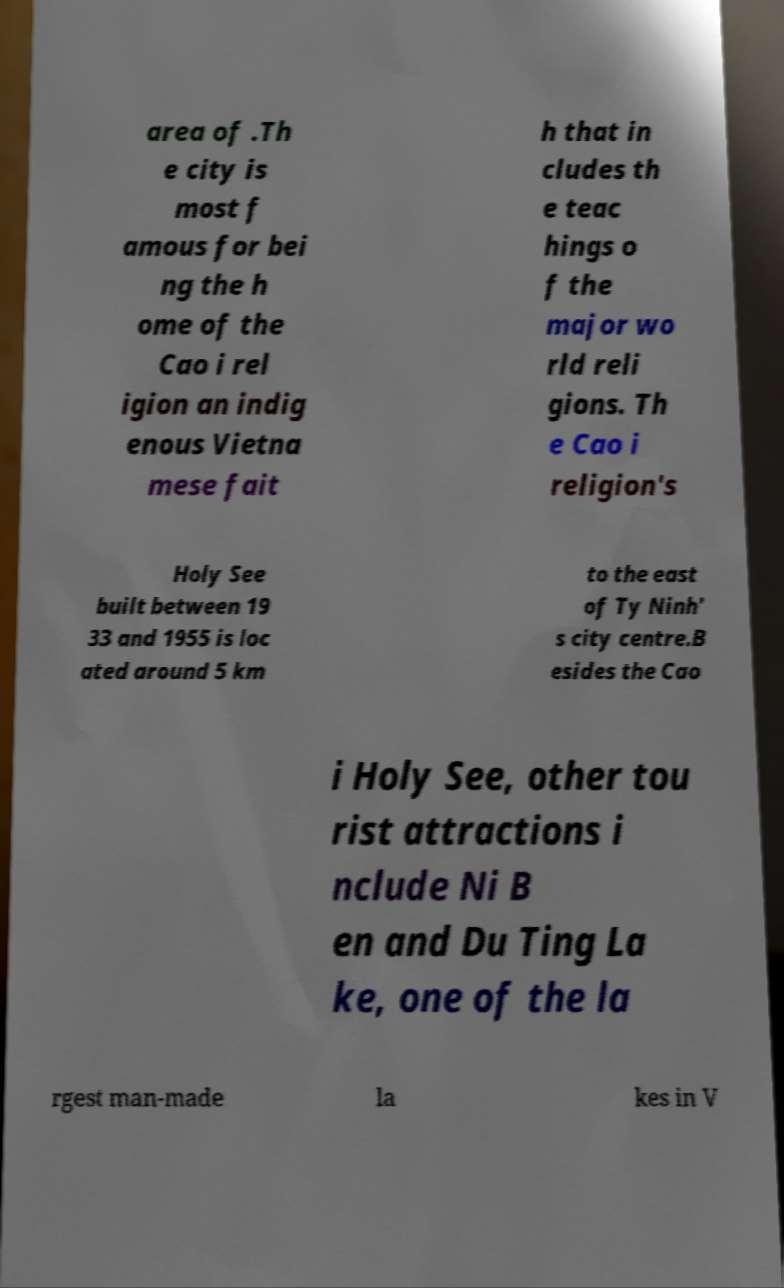I need the written content from this picture converted into text. Can you do that? area of .Th e city is most f amous for bei ng the h ome of the Cao i rel igion an indig enous Vietna mese fait h that in cludes th e teac hings o f the major wo rld reli gions. Th e Cao i religion's Holy See built between 19 33 and 1955 is loc ated around 5 km to the east of Ty Ninh' s city centre.B esides the Cao i Holy See, other tou rist attractions i nclude Ni B en and Du Ting La ke, one of the la rgest man-made la kes in V 